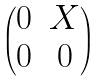<formula> <loc_0><loc_0><loc_500><loc_500>\begin{pmatrix} 0 & X \\ 0 & 0 \end{pmatrix}</formula> 